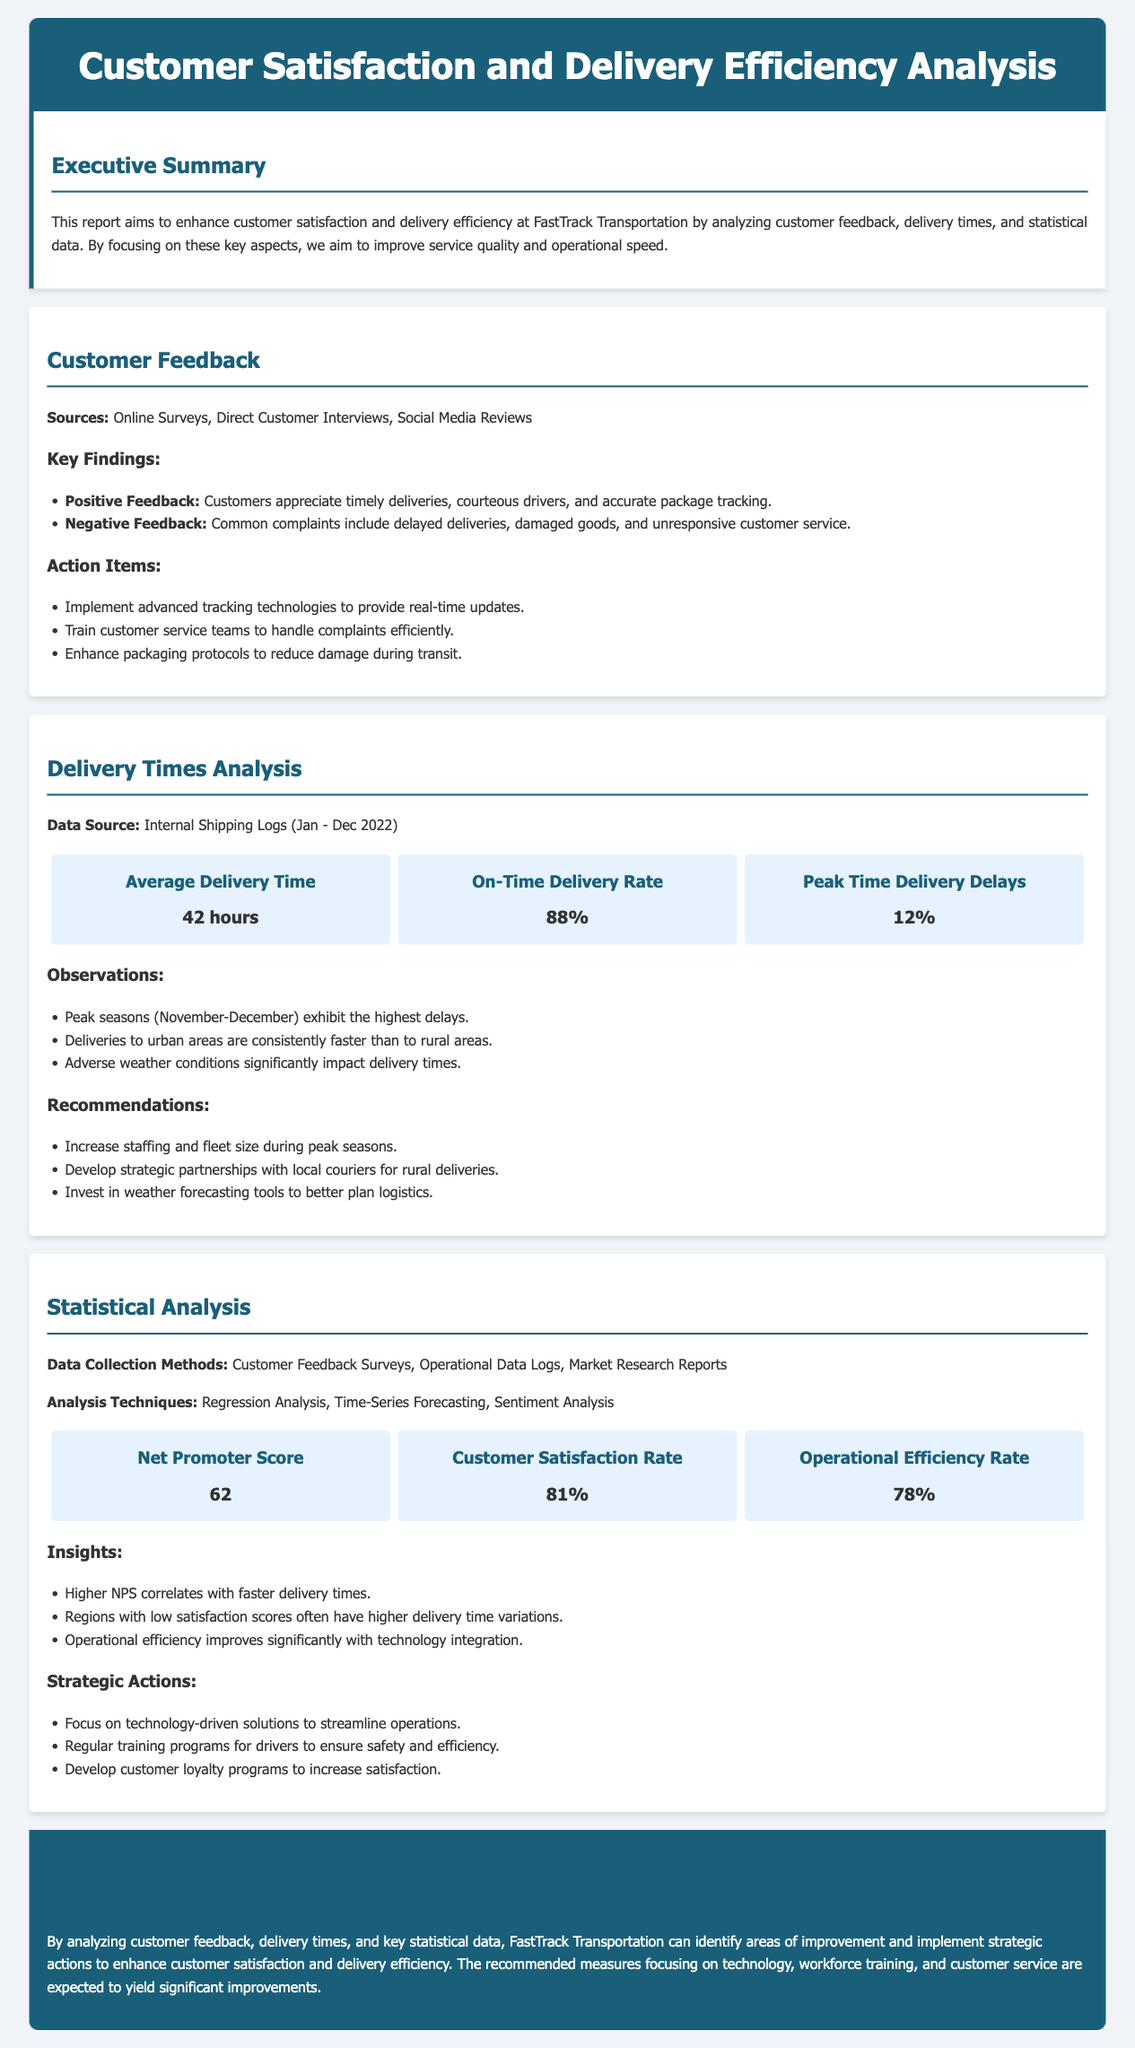What is the average delivery time? The average delivery time is calculated from internal shipping logs for the period in the document, which shows that the average delivery time is 42 hours.
Answer: 42 hours What is the on-time delivery rate? The on-time delivery rate is a key statistic mentioned in the delivery times analysis section, reported to be 88%.
Answer: 88% What technologies are recommended for implementation? The document lists several action items including advanced tracking technologies, which would enhance customer experience and reporting.
Answer: Advanced tracking technologies What is the Net Promoter Score? The Net Promoter Score is a calculated measure of customer loyalty, presented in the statistical analysis section, reported as 62.
Answer: 62 What are common complaints from customers? The document outlines specific negative feedback from customers, including delayed deliveries and damaged goods.
Answer: Delayed deliveries How do peak seasons affect delivery times? The observations in the delivery times analysis indicate that peak seasons, particularly November-December, exhibit the highest delays.
Answer: Highest delays What correlation was found between NPS and delivery times? Insights derived from the statistical analysis indicate that a higher NPS correlates with faster delivery times.
Answer: Faster delivery times Which region has the highest variation in delivery times? The insights suggest that regions with low customer satisfaction scores often have higher delivery time variations.
Answer: Low customer satisfaction scores What is the customer satisfaction rate? The customer satisfaction rate is an important statistic presented in the document, reported as 81%.
Answer: 81% 